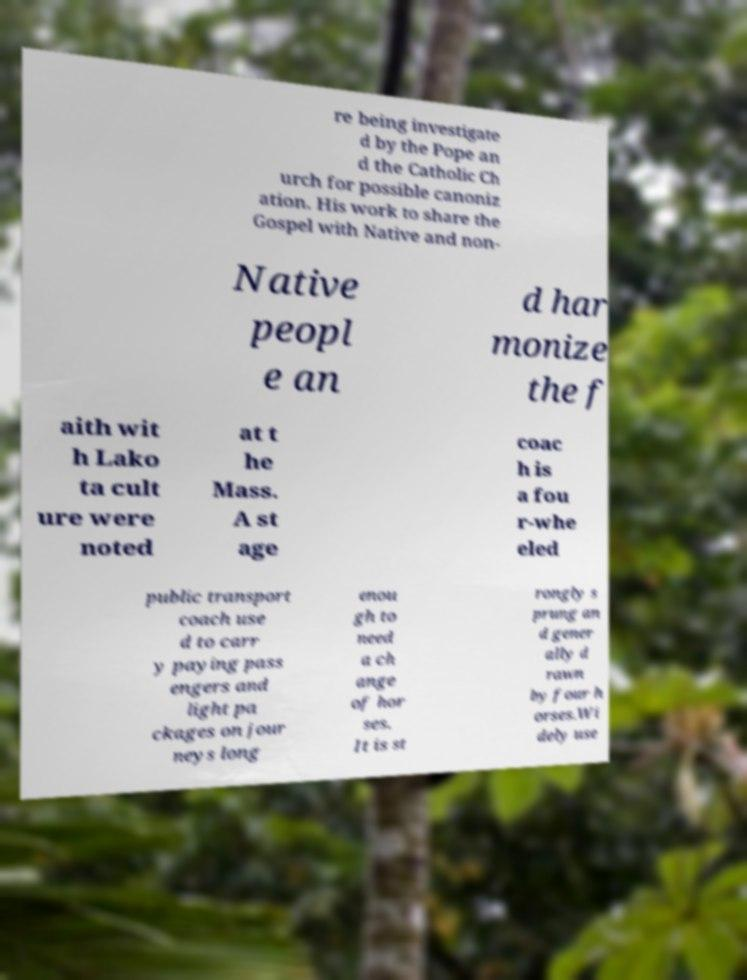Please identify and transcribe the text found in this image. re being investigate d by the Pope an d the Catholic Ch urch for possible canoniz ation. His work to share the Gospel with Native and non- Native peopl e an d har monize the f aith wit h Lako ta cult ure were noted at t he Mass. A st age coac h is a fou r-whe eled public transport coach use d to carr y paying pass engers and light pa ckages on jour neys long enou gh to need a ch ange of hor ses. It is st rongly s prung an d gener ally d rawn by four h orses.Wi dely use 